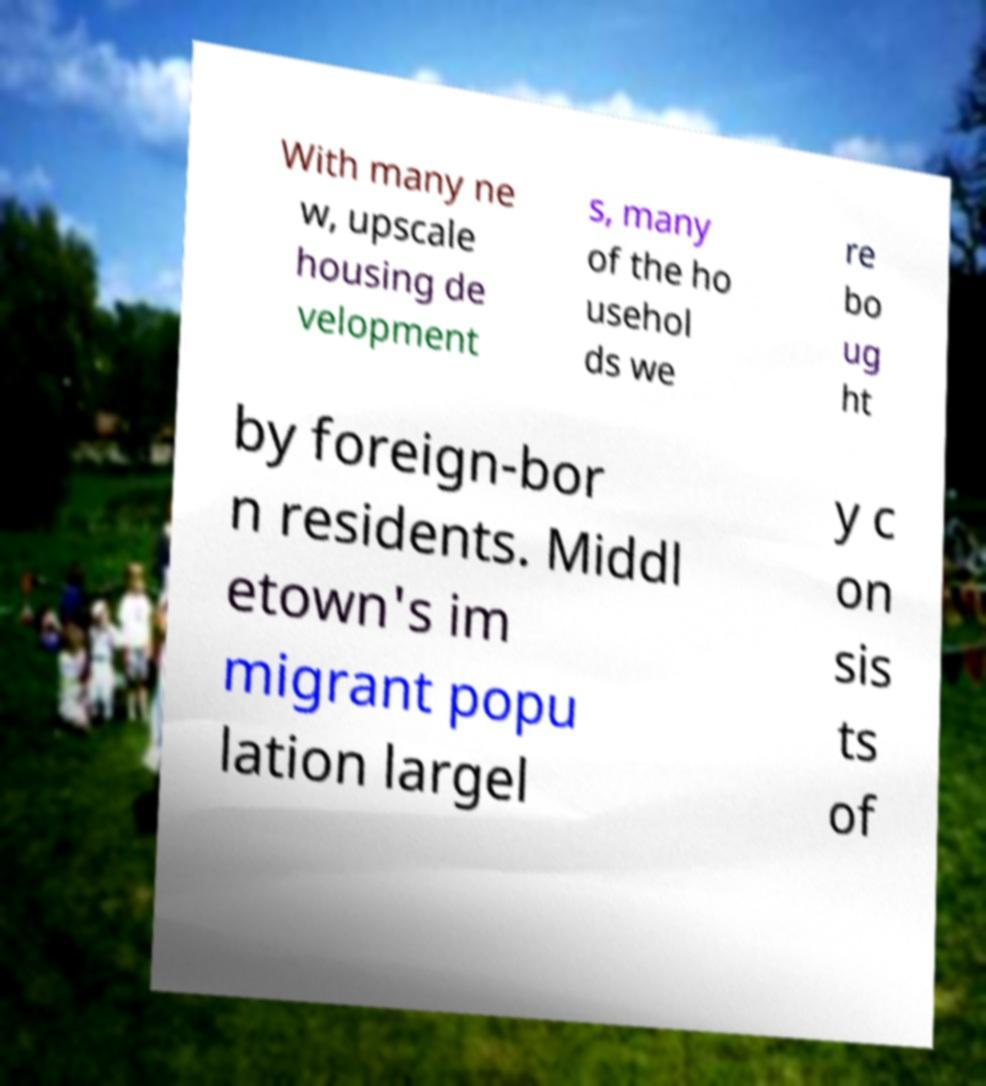Could you extract and type out the text from this image? With many ne w, upscale housing de velopment s, many of the ho usehol ds we re bo ug ht by foreign-bor n residents. Middl etown's im migrant popu lation largel y c on sis ts of 